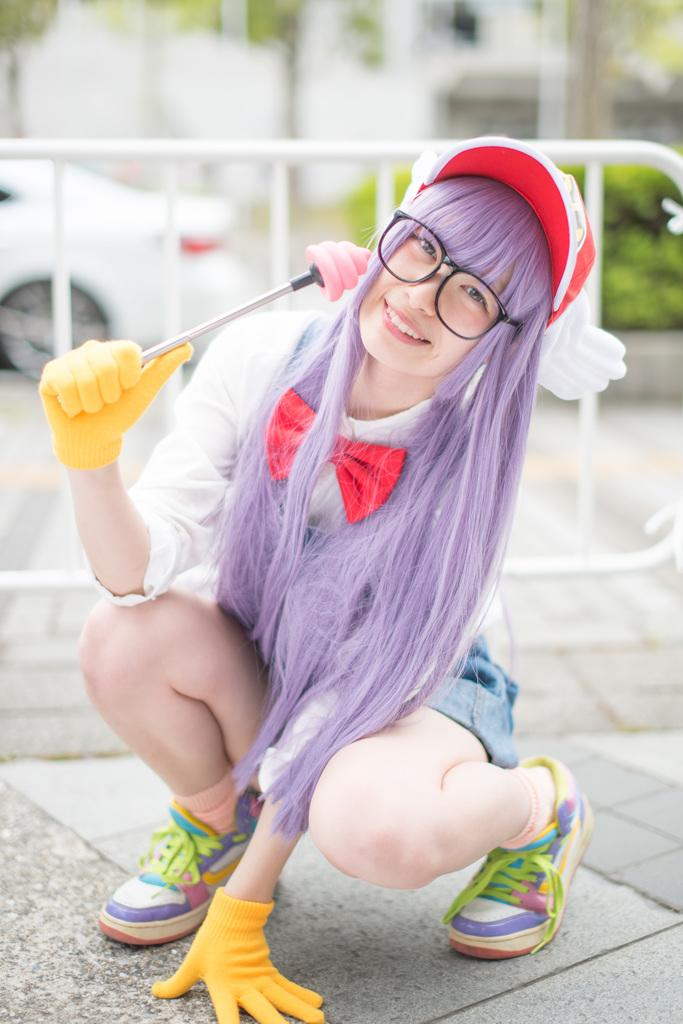What is the person in the image holding? There is a person holding an object in the image. What can be seen in the image that might be used for support or safety? There is a railing in the image. What is visible in the background of the image? There is a car and trees in the background of the image. What time does the clock show in the image? There is no clock present in the image. Is the boat visible in the image? There is no boat present in the image. 